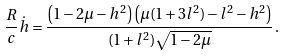Convert formula to latex. <formula><loc_0><loc_0><loc_500><loc_500>\frac { R } { c } \dot { h } = \frac { \left ( 1 - 2 \mu - h ^ { 2 } \right ) \left ( \mu ( 1 + 3 l ^ { 2 } ) - l ^ { 2 } - h ^ { 2 } \right ) } { ( 1 + l ^ { 2 } ) \sqrt { 1 - 2 \mu } } \, .</formula> 